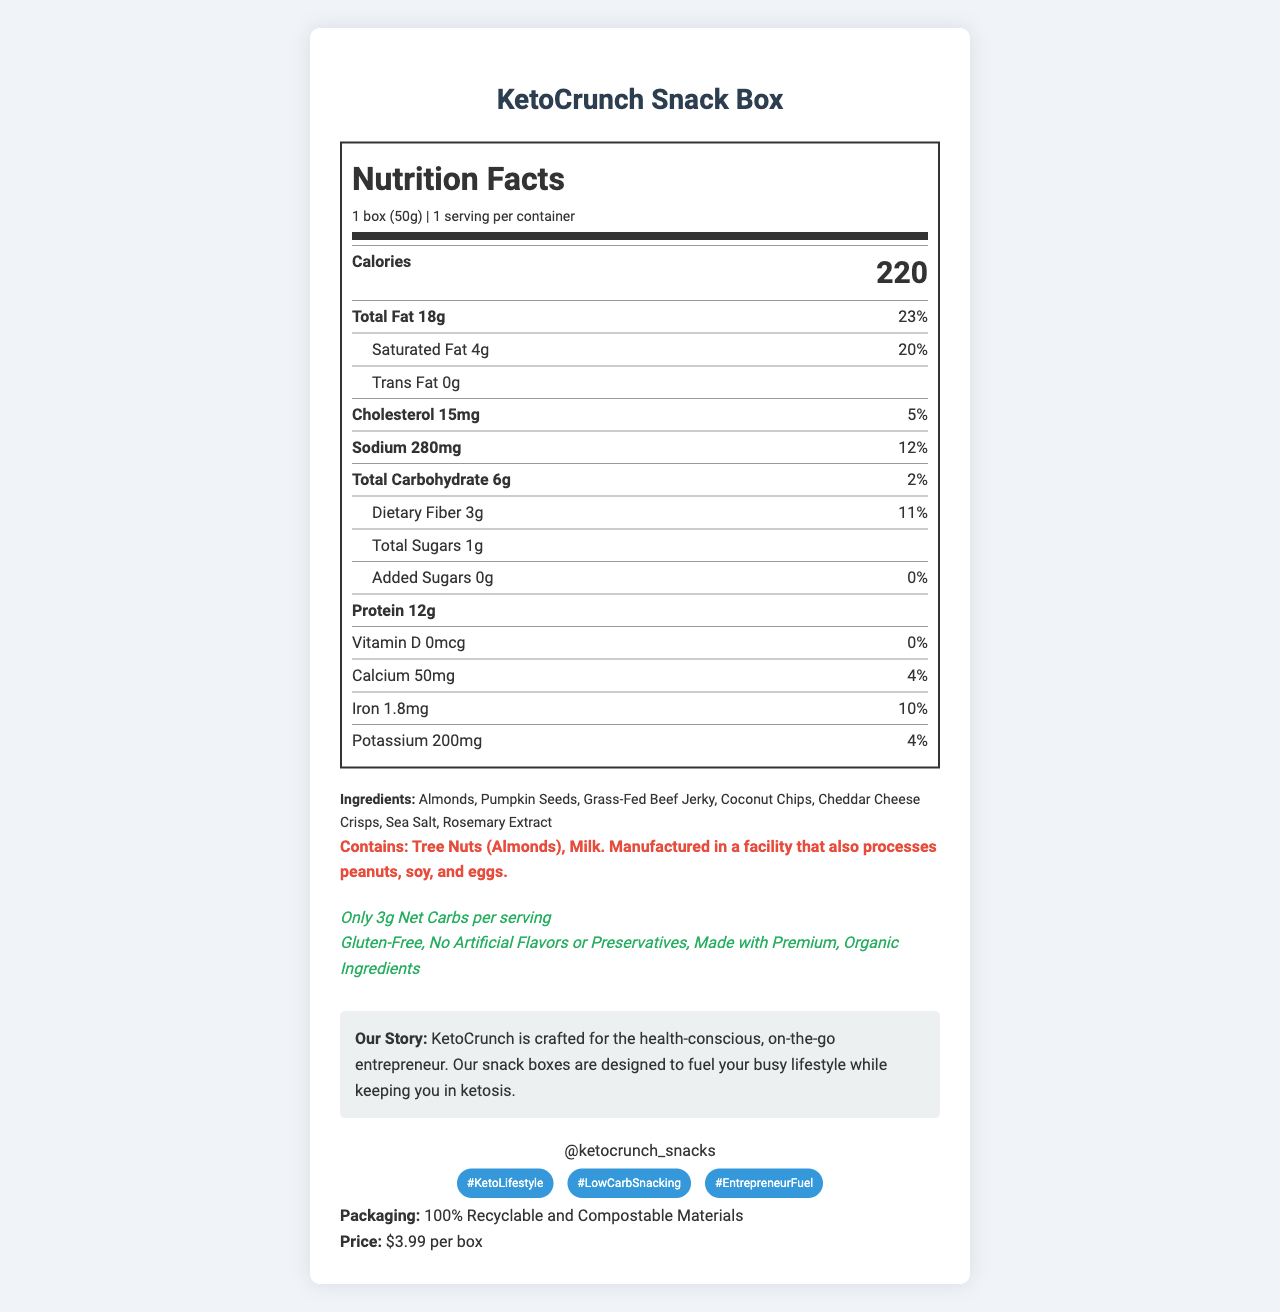what is the serving size? The serving size is listed at the beginning of the Nutrition Facts section as “1 box (50g).”
Answer: 1 box (50g) how much sodium is in each serving? The amount of sodium is clearly stated in the nutrient breakdown as “Sodium 280mg.”
Answer: 280mg how many grams of dietary fiber are in the KetoCrunch Snack Box? Under the carbohydrate section, it lists “Dietary Fiber 3g, 11% DV.”
Answer: 3g How many total carbohydrates does this snack contain? The total carbohydrates are listed as “Total Carbohydrate 6g, 2%.”
Answer: 6g which ingredient is the first listed? The first listed ingredient is "Almonds."
Answer: Almonds Which allergens are present in the product? A. Peanuts and Soy B. Tree Nuts and Milk C. Eggs and Wheat The allergen warning section states, “Contains: Tree Nuts (Almonds), Milk.”
Answer: B What is the daily value percentage for saturated fat? A. 10% B. 15% C. 20% D. 25% The document states, "Saturated Fat 4g, 20% DV."
Answer: C Is this KetoCrunch Snack Box gluten-free? In the additional claims section, it states "Gluten-Free."
Answer: Yes summarize the key marketing points made about KetoCrunch Snack Box from the document. The summary includes the core message from the brand story, the target audience, key nutritional claims, and the price.
Answer: KetoCrunch Snack Box is a keto-friendly, low-carb snack option ideal for health-conscious millennials and Gen Z professionals. It contains only 3g net carbs, uses premium organic ingredients, is gluten-free, and made without artificial flavors or preservatives. The packaging is sustainable, and the price is $3.99 per box. how many servings are in each container? The serving information states "servings per container: 1."
Answer: 1 What is the main source of protein in this snack box? In the ingredients list, "Grass-Fed Beef Jerky" is listed as the main protein source.
Answer: Grass-Fed Beef Jerky What social media platform can you follow KetoCrunch on? The social media section lists the Instagram handle "@ketocrunch_snacks."
Answer: Instagram does this product include any artificial flavors or preservatives? The document explicitly claims "No Artificial Flavors or Preservatives."
Answer: No How much does one box of KetoCrunch Snack Box cost? The document clearly states the price as "$3.99 per box."
Answer: $3.99 which of these nutrients has a 0% daily value in KetoCrunch Snack Box? The nutrient breakdown lists "Vitamin D 0mcg, 0%."
Answer: Vitamin D how many grams of added sugars are in the snack box? The amount added sugars is explicitly stated as “Added Sugars 0g, 0%.”
Answer: 0g are eggs used as an ingredient in this snack? The document provides information on allergens processed in the facility but does not confirm whether eggs are an actual ingredient.
Answer: Cannot be determined 